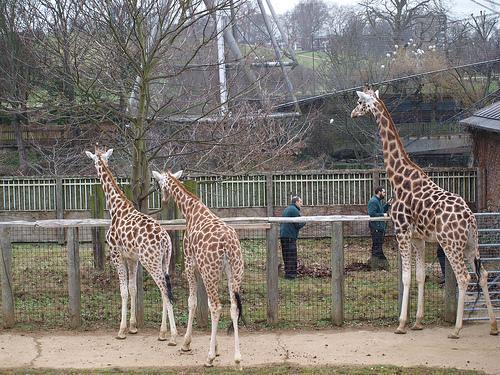How many giraffes are there?
Give a very brief answer. 3. 